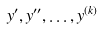<formula> <loc_0><loc_0><loc_500><loc_500>y ^ { \prime } , y ^ { \prime \prime } , \dots , y ^ { ( k ) }</formula> 